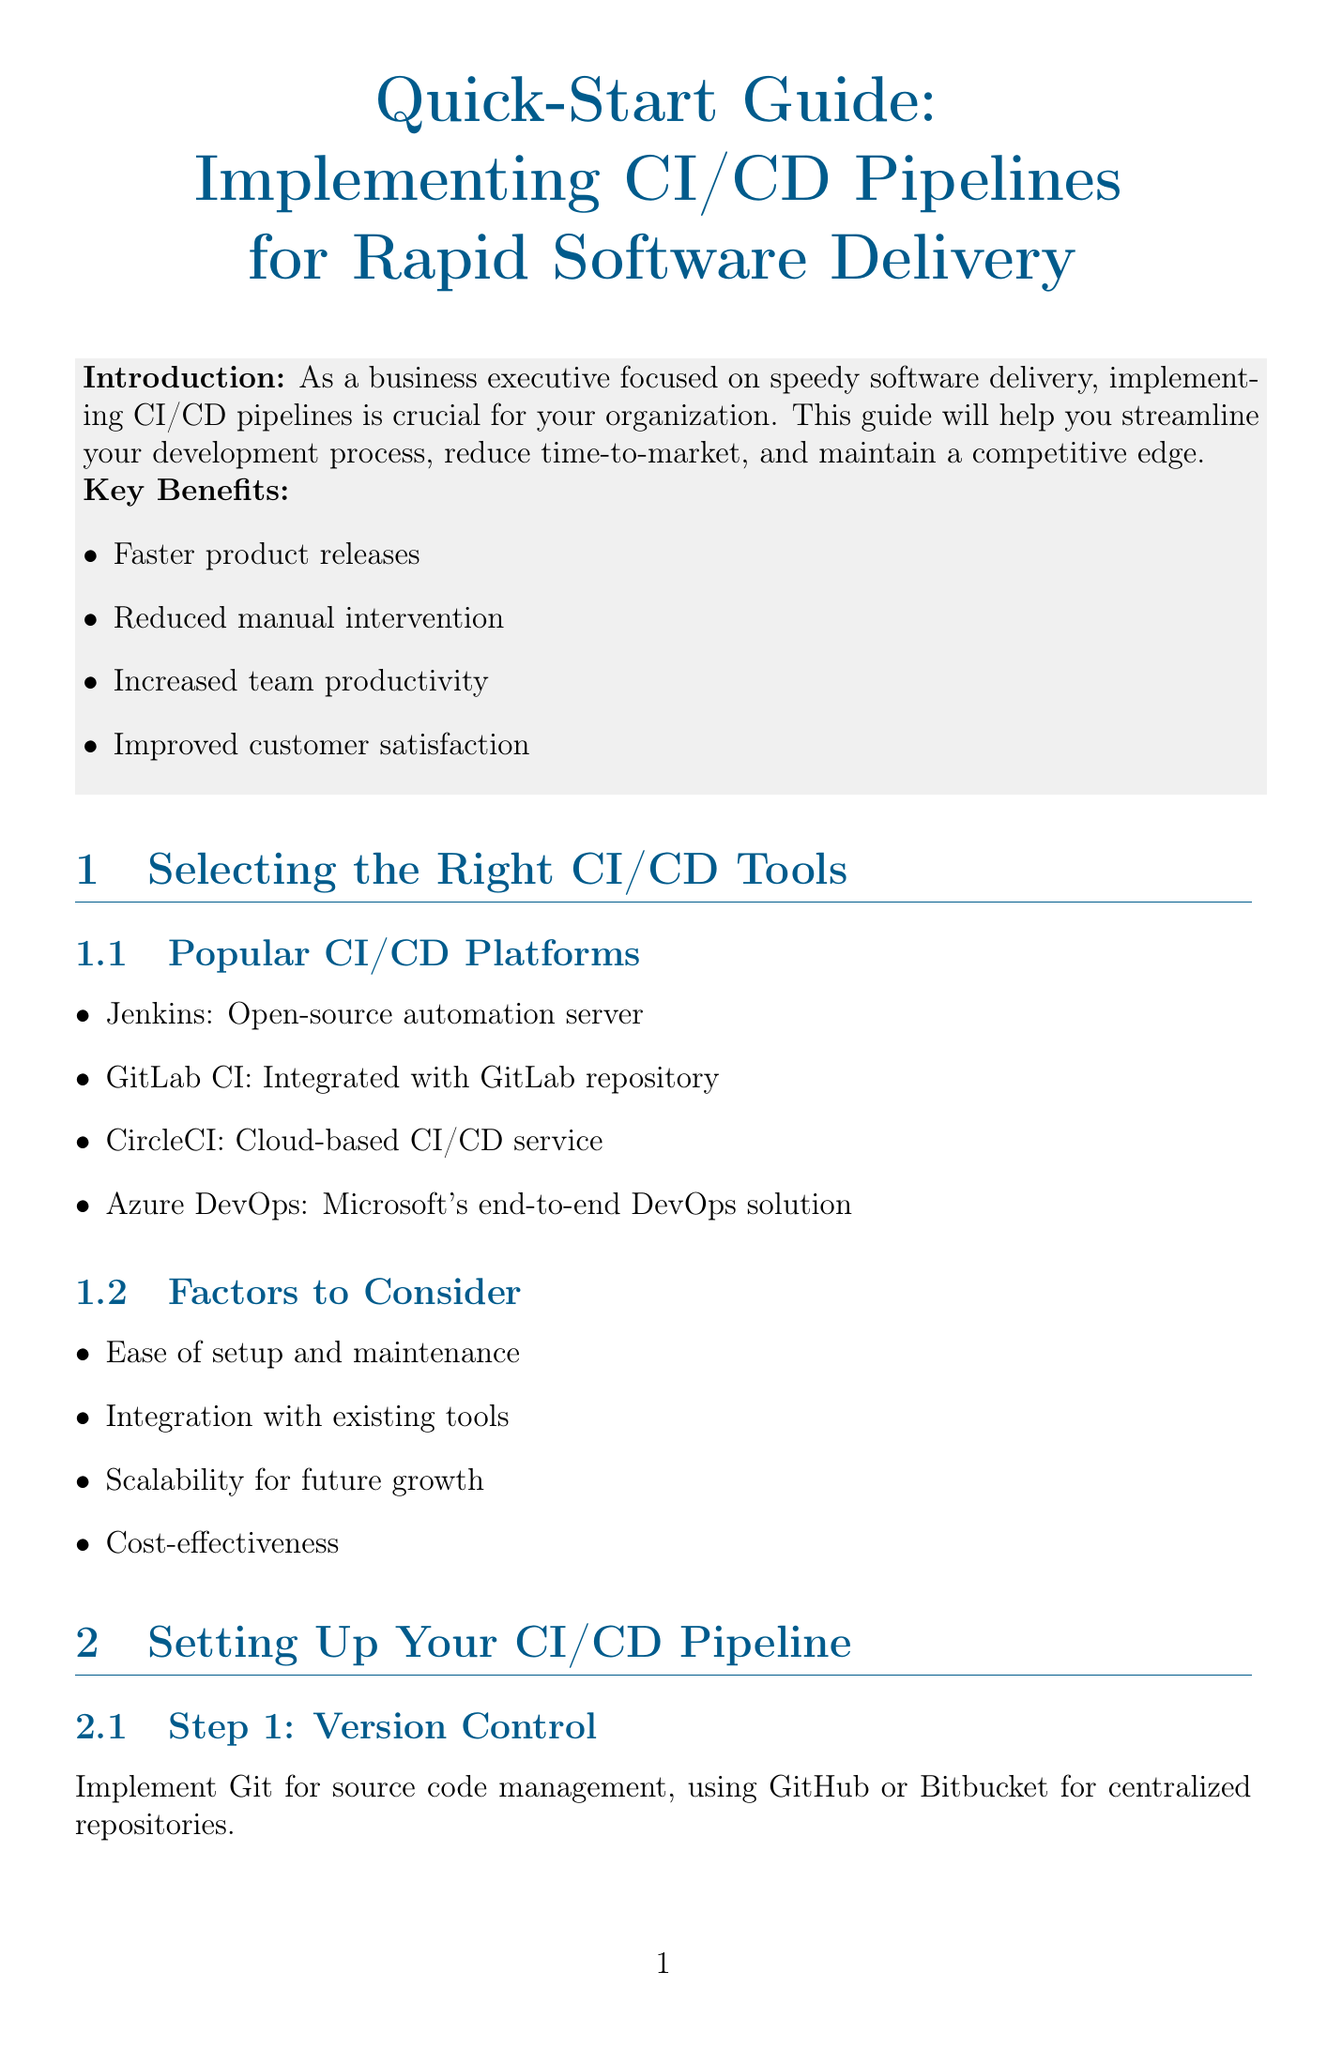What is the title of the guide? The title is found at the beginning of the document, which states the purpose of the guide.
Answer: Quick-Start Guide: Implementing CI/CD Pipelines for Rapid Software Delivery What is the first step in setting up a CI/CD pipeline? This information is located under the "Setting Up Your CI/CD Pipeline" section, outlining the initial actions required.
Answer: Version Control Which CI/CD platform is described as an open-source automation server? The document lists popular platforms, identifying that specific platform as open-source.
Answer: Jenkins What are the key benefits of implementing CI/CD pipelines? The introduction section highlights the advantages, which can be succinctly summarized.
Answer: Faster product releases, Reduced manual intervention, Increased team productivity, Improved customer satisfaction What is the purpose of feature flags? The "Best Practices for Rapid Delivery" section describes the implementation of feature flags and their benefits.
Answer: Deploy code to production without activating new features How can overall execution time be reduced in CI/CD? The document provides strategies for optimizing CI/CD processes, including specific techniques employed.
Answer: Parallel Execution What metric tracks the lead time for changes? In the "Monitoring and Optimization" section, several key metrics to track are listed.
Answer: Lead time for changes What is one recommended approach to enhance delivery speed? The guide provides various methods in the "Best Practices for Rapid Delivery" section to enhance software delivery efficiency.
Answer: Microservices Architecture 